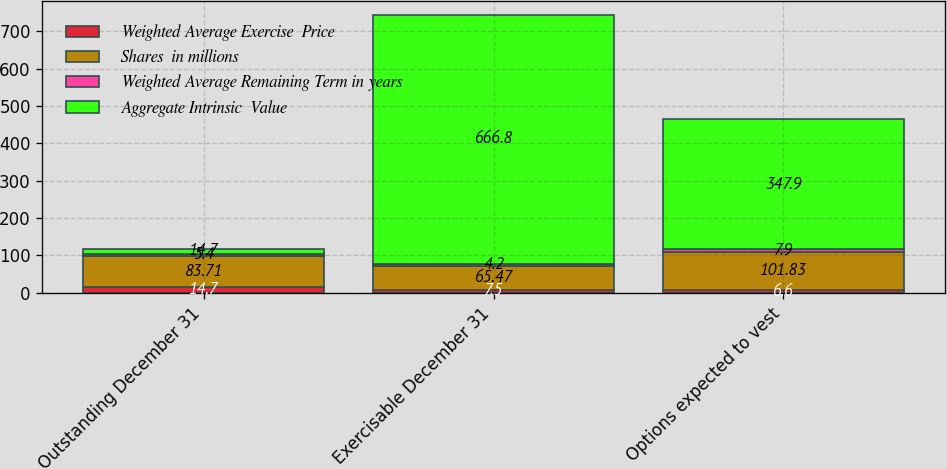Convert chart. <chart><loc_0><loc_0><loc_500><loc_500><stacked_bar_chart><ecel><fcel>Outstanding December 31<fcel>Exercisable December 31<fcel>Options expected to vest<nl><fcel>Weighted Average Exercise  Price<fcel>14.7<fcel>7.5<fcel>6.6<nl><fcel>Shares  in millions<fcel>83.71<fcel>65.47<fcel>101.83<nl><fcel>Weighted Average Remaining Term in years<fcel>5.4<fcel>4.2<fcel>7.9<nl><fcel>Aggregate Intrinsic  Value<fcel>14.7<fcel>666.8<fcel>347.9<nl></chart> 